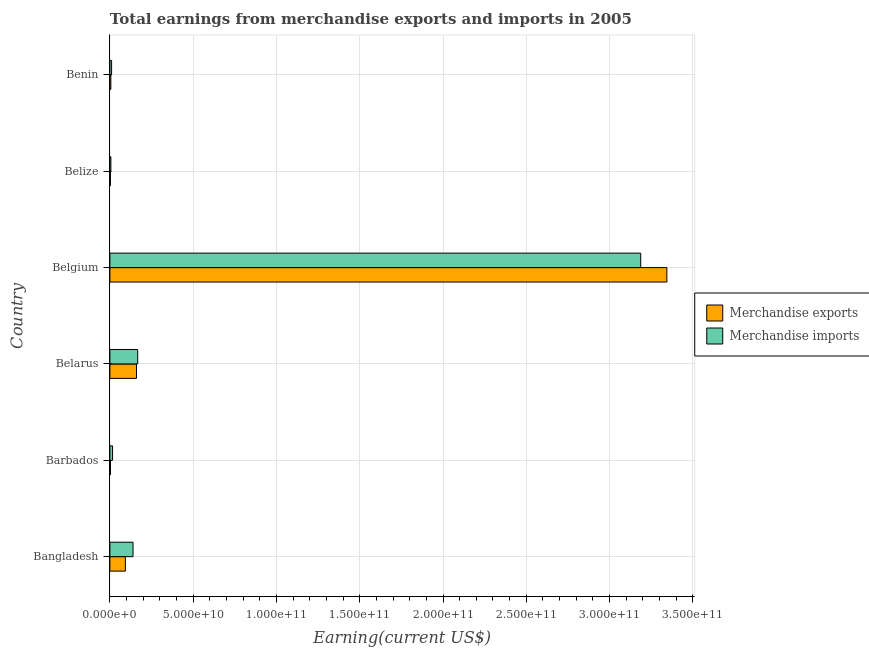How many different coloured bars are there?
Your answer should be compact. 2. Are the number of bars per tick equal to the number of legend labels?
Provide a succinct answer. Yes. How many bars are there on the 4th tick from the bottom?
Ensure brevity in your answer.  2. What is the label of the 3rd group of bars from the top?
Your answer should be compact. Belgium. In how many cases, is the number of bars for a given country not equal to the number of legend labels?
Offer a very short reply. 0. What is the earnings from merchandise exports in Belarus?
Provide a short and direct response. 1.60e+1. Across all countries, what is the maximum earnings from merchandise exports?
Ensure brevity in your answer.  3.34e+11. Across all countries, what is the minimum earnings from merchandise imports?
Offer a terse response. 5.93e+08. In which country was the earnings from merchandise imports minimum?
Provide a succinct answer. Belize. What is the total earnings from merchandise imports in the graph?
Your answer should be compact. 3.53e+11. What is the difference between the earnings from merchandise exports in Belgium and that in Belize?
Your answer should be compact. 3.34e+11. What is the difference between the earnings from merchandise imports in Belgium and the earnings from merchandise exports in Belize?
Offer a terse response. 3.18e+11. What is the average earnings from merchandise imports per country?
Keep it short and to the point. 5.88e+1. What is the difference between the earnings from merchandise imports and earnings from merchandise exports in Benin?
Ensure brevity in your answer.  4.40e+08. In how many countries, is the earnings from merchandise exports greater than 140000000000 US$?
Provide a succinct answer. 1. What is the ratio of the earnings from merchandise imports in Barbados to that in Belize?
Your answer should be compact. 2.71. Is the earnings from merchandise exports in Belarus less than that in Belize?
Ensure brevity in your answer.  No. What is the difference between the highest and the second highest earnings from merchandise imports?
Keep it short and to the point. 3.02e+11. What is the difference between the highest and the lowest earnings from merchandise exports?
Your answer should be compact. 3.34e+11. In how many countries, is the earnings from merchandise imports greater than the average earnings from merchandise imports taken over all countries?
Provide a succinct answer. 1. What does the 2nd bar from the bottom in Belize represents?
Offer a very short reply. Merchandise imports. How many bars are there?
Ensure brevity in your answer.  12. Are the values on the major ticks of X-axis written in scientific E-notation?
Provide a succinct answer. Yes. Does the graph contain any zero values?
Your answer should be very brief. No. Where does the legend appear in the graph?
Your response must be concise. Center right. How are the legend labels stacked?
Provide a short and direct response. Vertical. What is the title of the graph?
Your answer should be compact. Total earnings from merchandise exports and imports in 2005. What is the label or title of the X-axis?
Your answer should be compact. Earning(current US$). What is the Earning(current US$) of Merchandise exports in Bangladesh?
Provide a succinct answer. 9.30e+09. What is the Earning(current US$) in Merchandise imports in Bangladesh?
Offer a terse response. 1.39e+1. What is the Earning(current US$) of Merchandise exports in Barbados?
Your answer should be very brief. 3.59e+08. What is the Earning(current US$) of Merchandise imports in Barbados?
Keep it short and to the point. 1.60e+09. What is the Earning(current US$) in Merchandise exports in Belarus?
Your response must be concise. 1.60e+1. What is the Earning(current US$) of Merchandise imports in Belarus?
Ensure brevity in your answer.  1.67e+1. What is the Earning(current US$) of Merchandise exports in Belgium?
Make the answer very short. 3.34e+11. What is the Earning(current US$) in Merchandise imports in Belgium?
Ensure brevity in your answer.  3.19e+11. What is the Earning(current US$) in Merchandise exports in Belize?
Ensure brevity in your answer.  3.19e+08. What is the Earning(current US$) of Merchandise imports in Belize?
Make the answer very short. 5.93e+08. What is the Earning(current US$) of Merchandise exports in Benin?
Your answer should be compact. 5.78e+08. What is the Earning(current US$) of Merchandise imports in Benin?
Keep it short and to the point. 1.02e+09. Across all countries, what is the maximum Earning(current US$) in Merchandise exports?
Provide a succinct answer. 3.34e+11. Across all countries, what is the maximum Earning(current US$) of Merchandise imports?
Ensure brevity in your answer.  3.19e+11. Across all countries, what is the minimum Earning(current US$) in Merchandise exports?
Provide a succinct answer. 3.19e+08. Across all countries, what is the minimum Earning(current US$) in Merchandise imports?
Your answer should be very brief. 5.93e+08. What is the total Earning(current US$) of Merchandise exports in the graph?
Your answer should be very brief. 3.61e+11. What is the total Earning(current US$) of Merchandise imports in the graph?
Offer a very short reply. 3.53e+11. What is the difference between the Earning(current US$) of Merchandise exports in Bangladesh and that in Barbados?
Offer a very short reply. 8.94e+09. What is the difference between the Earning(current US$) of Merchandise imports in Bangladesh and that in Barbados?
Provide a succinct answer. 1.23e+1. What is the difference between the Earning(current US$) of Merchandise exports in Bangladesh and that in Belarus?
Your response must be concise. -6.68e+09. What is the difference between the Earning(current US$) of Merchandise imports in Bangladesh and that in Belarus?
Offer a terse response. -2.82e+09. What is the difference between the Earning(current US$) in Merchandise exports in Bangladesh and that in Belgium?
Make the answer very short. -3.25e+11. What is the difference between the Earning(current US$) of Merchandise imports in Bangladesh and that in Belgium?
Make the answer very short. -3.05e+11. What is the difference between the Earning(current US$) of Merchandise exports in Bangladesh and that in Belize?
Offer a very short reply. 8.98e+09. What is the difference between the Earning(current US$) of Merchandise imports in Bangladesh and that in Belize?
Keep it short and to the point. 1.33e+1. What is the difference between the Earning(current US$) of Merchandise exports in Bangladesh and that in Benin?
Provide a short and direct response. 8.72e+09. What is the difference between the Earning(current US$) in Merchandise imports in Bangladesh and that in Benin?
Offer a very short reply. 1.29e+1. What is the difference between the Earning(current US$) in Merchandise exports in Barbados and that in Belarus?
Your answer should be very brief. -1.56e+1. What is the difference between the Earning(current US$) of Merchandise imports in Barbados and that in Belarus?
Your answer should be compact. -1.51e+1. What is the difference between the Earning(current US$) of Merchandise exports in Barbados and that in Belgium?
Your response must be concise. -3.34e+11. What is the difference between the Earning(current US$) in Merchandise imports in Barbados and that in Belgium?
Provide a short and direct response. -3.17e+11. What is the difference between the Earning(current US$) of Merchandise exports in Barbados and that in Belize?
Provide a short and direct response. 4.03e+07. What is the difference between the Earning(current US$) in Merchandise imports in Barbados and that in Belize?
Your answer should be compact. 1.01e+09. What is the difference between the Earning(current US$) of Merchandise exports in Barbados and that in Benin?
Your answer should be very brief. -2.19e+08. What is the difference between the Earning(current US$) in Merchandise imports in Barbados and that in Benin?
Give a very brief answer. 5.86e+08. What is the difference between the Earning(current US$) in Merchandise exports in Belarus and that in Belgium?
Your answer should be very brief. -3.18e+11. What is the difference between the Earning(current US$) in Merchandise imports in Belarus and that in Belgium?
Offer a very short reply. -3.02e+11. What is the difference between the Earning(current US$) of Merchandise exports in Belarus and that in Belize?
Provide a succinct answer. 1.57e+1. What is the difference between the Earning(current US$) of Merchandise imports in Belarus and that in Belize?
Your answer should be compact. 1.61e+1. What is the difference between the Earning(current US$) of Merchandise exports in Belarus and that in Benin?
Offer a very short reply. 1.54e+1. What is the difference between the Earning(current US$) in Merchandise imports in Belarus and that in Benin?
Your response must be concise. 1.57e+1. What is the difference between the Earning(current US$) in Merchandise exports in Belgium and that in Belize?
Your response must be concise. 3.34e+11. What is the difference between the Earning(current US$) of Merchandise imports in Belgium and that in Belize?
Your answer should be compact. 3.18e+11. What is the difference between the Earning(current US$) in Merchandise exports in Belgium and that in Benin?
Offer a very short reply. 3.34e+11. What is the difference between the Earning(current US$) of Merchandise imports in Belgium and that in Benin?
Your answer should be very brief. 3.18e+11. What is the difference between the Earning(current US$) of Merchandise exports in Belize and that in Benin?
Ensure brevity in your answer.  -2.59e+08. What is the difference between the Earning(current US$) of Merchandise imports in Belize and that in Benin?
Your answer should be very brief. -4.25e+08. What is the difference between the Earning(current US$) in Merchandise exports in Bangladesh and the Earning(current US$) in Merchandise imports in Barbados?
Give a very brief answer. 7.69e+09. What is the difference between the Earning(current US$) of Merchandise exports in Bangladesh and the Earning(current US$) of Merchandise imports in Belarus?
Provide a short and direct response. -7.41e+09. What is the difference between the Earning(current US$) in Merchandise exports in Bangladesh and the Earning(current US$) in Merchandise imports in Belgium?
Offer a terse response. -3.09e+11. What is the difference between the Earning(current US$) of Merchandise exports in Bangladesh and the Earning(current US$) of Merchandise imports in Belize?
Ensure brevity in your answer.  8.70e+09. What is the difference between the Earning(current US$) of Merchandise exports in Bangladesh and the Earning(current US$) of Merchandise imports in Benin?
Your answer should be compact. 8.28e+09. What is the difference between the Earning(current US$) of Merchandise exports in Barbados and the Earning(current US$) of Merchandise imports in Belarus?
Provide a succinct answer. -1.63e+1. What is the difference between the Earning(current US$) of Merchandise exports in Barbados and the Earning(current US$) of Merchandise imports in Belgium?
Ensure brevity in your answer.  -3.18e+11. What is the difference between the Earning(current US$) of Merchandise exports in Barbados and the Earning(current US$) of Merchandise imports in Belize?
Provide a short and direct response. -2.33e+08. What is the difference between the Earning(current US$) of Merchandise exports in Barbados and the Earning(current US$) of Merchandise imports in Benin?
Provide a succinct answer. -6.59e+08. What is the difference between the Earning(current US$) in Merchandise exports in Belarus and the Earning(current US$) in Merchandise imports in Belgium?
Make the answer very short. -3.03e+11. What is the difference between the Earning(current US$) in Merchandise exports in Belarus and the Earning(current US$) in Merchandise imports in Belize?
Give a very brief answer. 1.54e+1. What is the difference between the Earning(current US$) in Merchandise exports in Belarus and the Earning(current US$) in Merchandise imports in Benin?
Give a very brief answer. 1.50e+1. What is the difference between the Earning(current US$) of Merchandise exports in Belgium and the Earning(current US$) of Merchandise imports in Belize?
Give a very brief answer. 3.34e+11. What is the difference between the Earning(current US$) in Merchandise exports in Belgium and the Earning(current US$) in Merchandise imports in Benin?
Offer a very short reply. 3.33e+11. What is the difference between the Earning(current US$) in Merchandise exports in Belize and the Earning(current US$) in Merchandise imports in Benin?
Keep it short and to the point. -6.99e+08. What is the average Earning(current US$) of Merchandise exports per country?
Your response must be concise. 6.02e+1. What is the average Earning(current US$) in Merchandise imports per country?
Make the answer very short. 5.88e+1. What is the difference between the Earning(current US$) in Merchandise exports and Earning(current US$) in Merchandise imports in Bangladesh?
Your response must be concise. -4.59e+09. What is the difference between the Earning(current US$) of Merchandise exports and Earning(current US$) of Merchandise imports in Barbados?
Your answer should be very brief. -1.24e+09. What is the difference between the Earning(current US$) of Merchandise exports and Earning(current US$) of Merchandise imports in Belarus?
Your answer should be very brief. -7.29e+08. What is the difference between the Earning(current US$) of Merchandise exports and Earning(current US$) of Merchandise imports in Belgium?
Your answer should be very brief. 1.57e+1. What is the difference between the Earning(current US$) in Merchandise exports and Earning(current US$) in Merchandise imports in Belize?
Provide a succinct answer. -2.74e+08. What is the difference between the Earning(current US$) of Merchandise exports and Earning(current US$) of Merchandise imports in Benin?
Keep it short and to the point. -4.40e+08. What is the ratio of the Earning(current US$) of Merchandise exports in Bangladesh to that in Barbados?
Make the answer very short. 25.86. What is the ratio of the Earning(current US$) in Merchandise imports in Bangladesh to that in Barbados?
Ensure brevity in your answer.  8.66. What is the ratio of the Earning(current US$) of Merchandise exports in Bangladesh to that in Belarus?
Give a very brief answer. 0.58. What is the ratio of the Earning(current US$) in Merchandise imports in Bangladesh to that in Belarus?
Make the answer very short. 0.83. What is the ratio of the Earning(current US$) of Merchandise exports in Bangladesh to that in Belgium?
Your answer should be compact. 0.03. What is the ratio of the Earning(current US$) in Merchandise imports in Bangladesh to that in Belgium?
Keep it short and to the point. 0.04. What is the ratio of the Earning(current US$) of Merchandise exports in Bangladesh to that in Belize?
Ensure brevity in your answer.  29.13. What is the ratio of the Earning(current US$) in Merchandise imports in Bangladesh to that in Belize?
Give a very brief answer. 23.42. What is the ratio of the Earning(current US$) in Merchandise exports in Bangladesh to that in Benin?
Keep it short and to the point. 16.08. What is the ratio of the Earning(current US$) in Merchandise imports in Bangladesh to that in Benin?
Keep it short and to the point. 13.64. What is the ratio of the Earning(current US$) of Merchandise exports in Barbados to that in Belarus?
Offer a very short reply. 0.02. What is the ratio of the Earning(current US$) in Merchandise imports in Barbados to that in Belarus?
Your response must be concise. 0.1. What is the ratio of the Earning(current US$) in Merchandise exports in Barbados to that in Belgium?
Provide a short and direct response. 0. What is the ratio of the Earning(current US$) of Merchandise imports in Barbados to that in Belgium?
Offer a very short reply. 0.01. What is the ratio of the Earning(current US$) of Merchandise exports in Barbados to that in Belize?
Offer a very short reply. 1.13. What is the ratio of the Earning(current US$) in Merchandise imports in Barbados to that in Belize?
Your answer should be compact. 2.71. What is the ratio of the Earning(current US$) of Merchandise exports in Barbados to that in Benin?
Your answer should be compact. 0.62. What is the ratio of the Earning(current US$) of Merchandise imports in Barbados to that in Benin?
Make the answer very short. 1.58. What is the ratio of the Earning(current US$) of Merchandise exports in Belarus to that in Belgium?
Your response must be concise. 0.05. What is the ratio of the Earning(current US$) of Merchandise imports in Belarus to that in Belgium?
Your response must be concise. 0.05. What is the ratio of the Earning(current US$) of Merchandise exports in Belarus to that in Belize?
Your answer should be compact. 50.07. What is the ratio of the Earning(current US$) of Merchandise imports in Belarus to that in Belize?
Your response must be concise. 28.18. What is the ratio of the Earning(current US$) in Merchandise exports in Belarus to that in Benin?
Provide a succinct answer. 27.63. What is the ratio of the Earning(current US$) of Merchandise imports in Belarus to that in Benin?
Make the answer very short. 16.41. What is the ratio of the Earning(current US$) in Merchandise exports in Belgium to that in Belize?
Provide a short and direct response. 1047.91. What is the ratio of the Earning(current US$) of Merchandise imports in Belgium to that in Belize?
Make the answer very short. 537.49. What is the ratio of the Earning(current US$) of Merchandise exports in Belgium to that in Benin?
Provide a short and direct response. 578.31. What is the ratio of the Earning(current US$) in Merchandise imports in Belgium to that in Benin?
Provide a succinct answer. 313.06. What is the ratio of the Earning(current US$) of Merchandise exports in Belize to that in Benin?
Your response must be concise. 0.55. What is the ratio of the Earning(current US$) in Merchandise imports in Belize to that in Benin?
Your response must be concise. 0.58. What is the difference between the highest and the second highest Earning(current US$) of Merchandise exports?
Your answer should be very brief. 3.18e+11. What is the difference between the highest and the second highest Earning(current US$) in Merchandise imports?
Keep it short and to the point. 3.02e+11. What is the difference between the highest and the lowest Earning(current US$) of Merchandise exports?
Keep it short and to the point. 3.34e+11. What is the difference between the highest and the lowest Earning(current US$) in Merchandise imports?
Your response must be concise. 3.18e+11. 